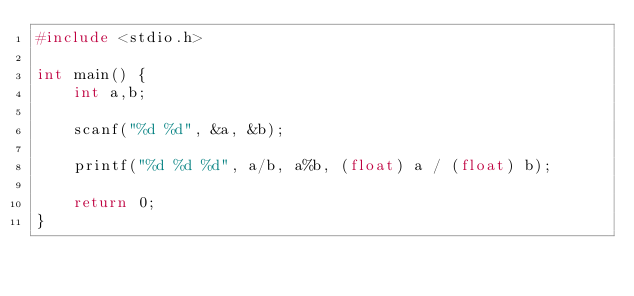<code> <loc_0><loc_0><loc_500><loc_500><_C_>#include <stdio.h>

int main() {
    int a,b;

    scanf("%d %d", &a, &b);

    printf("%d %d %d", a/b, a%b, (float) a / (float) b);

    return 0;
}

</code> 